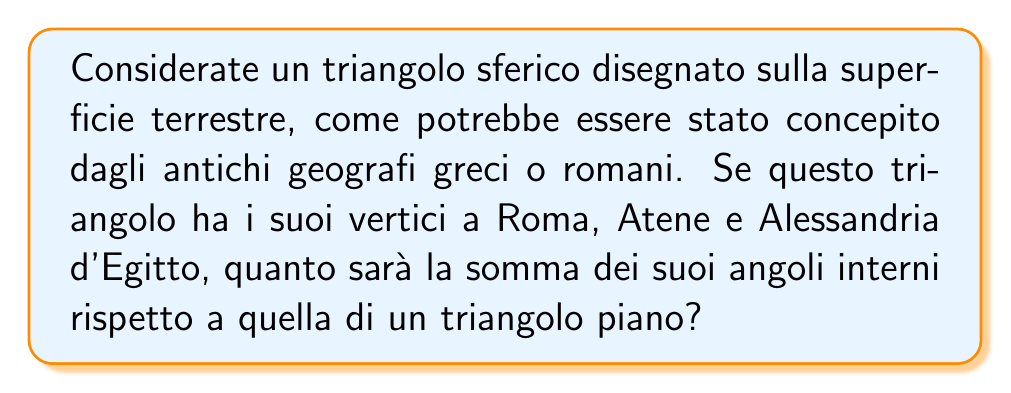Can you answer this question? Per risolvere questo problema, seguiamo questi passaggi:

1) In geometria euclidea piana, la somma degli angoli interni di un triangolo è sempre 180°. Tuttavia, su una superficie sferica come la Terra, questa regola non si applica.

2) Su una sfera, la somma degli angoli interni di un triangolo è sempre maggiore di 180°. L'eccesso rispetto a 180° è proporzionale all'area del triangolo sulla superficie sferica.

3) La formula per calcolare la somma degli angoli interni di un triangolo sferico è:

   $$ S = 180° + \frac{A}{R^2} \cdot \frac{180°}{\pi} $$

   Dove $S$ è la somma degli angoli, $A$ è l'area del triangolo sulla superficie sferica, e $R$ è il raggio della sfera.

4) Per il nostro triangolo Roma-Atene-Alessandria, non abbiamo dati precisi sull'area, ma possiamo fare alcune considerazioni:

   - Il triangolo copre una porzione significativa del Mediterraneo.
   - L'area di questo triangolo è molto piccola rispetto alla superficie totale della Terra.

5) Supponiamo che l'area del nostro triangolo sia circa lo 0.1% della superficie terrestre. La superficie della Terra è approssimativamente 510 milioni di km².

   $A \approx 510.000.000 \cdot 0.001 = 510.000 \text{ km}^2$

6) Il raggio medio della Terra è circa 6371 km.

7) Sostituendo questi valori nella formula:

   $$ S \approx 180° + \frac{510.000}{6371^2} \cdot \frac{180°}{\pi} \approx 180° + 0.71° $$

8) Quindi, la somma degli angoli interni del nostro triangolo sferico sarà circa 180.71°.
Answer: $180.71°$ 